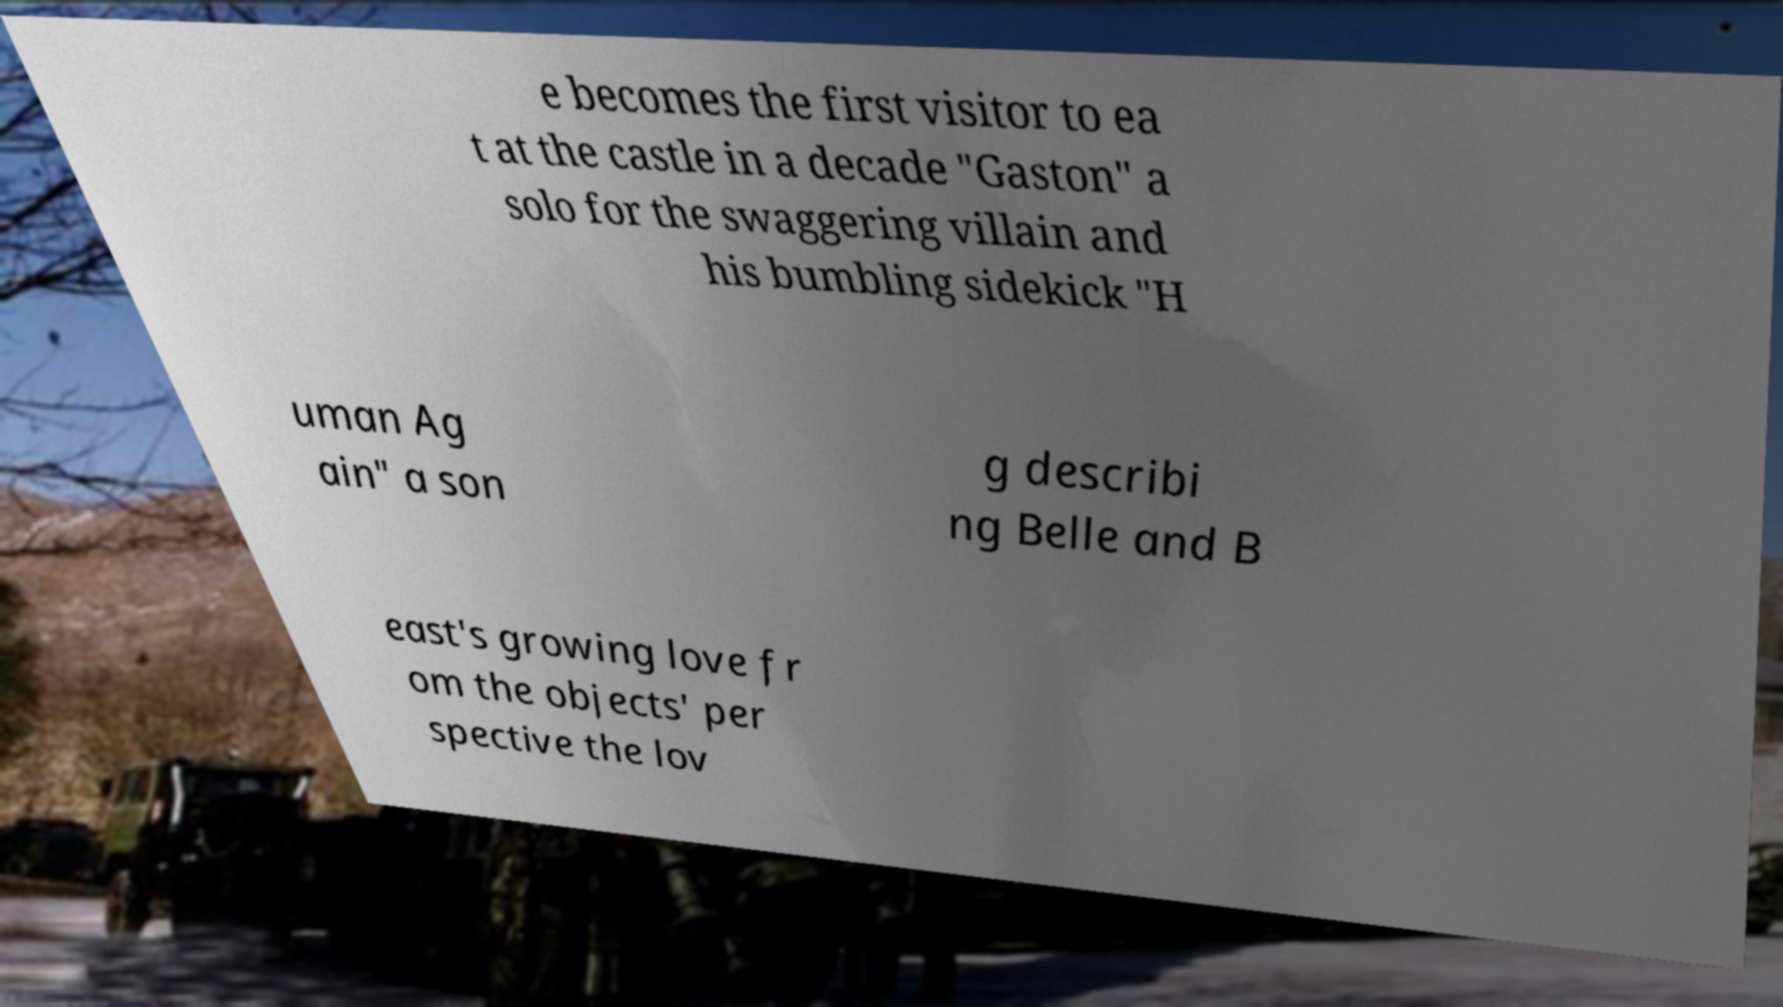For documentation purposes, I need the text within this image transcribed. Could you provide that? e becomes the first visitor to ea t at the castle in a decade "Gaston" a solo for the swaggering villain and his bumbling sidekick "H uman Ag ain" a son g describi ng Belle and B east's growing love fr om the objects' per spective the lov 